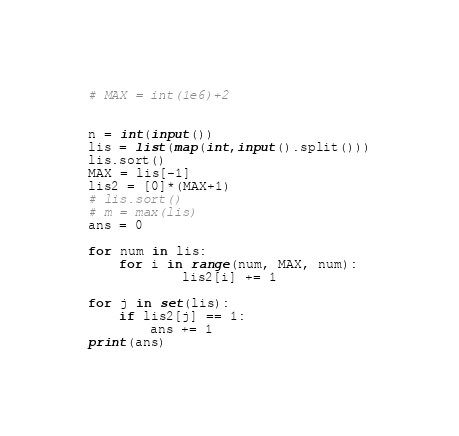<code> <loc_0><loc_0><loc_500><loc_500><_Python_># MAX = int(1e6)+2


n = int(input())
lis = list(map(int,input().split()))
lis.sort()
MAX = lis[-1]
lis2 = [0]*(MAX+1)
# lis.sort()
# m = max(lis)
ans = 0

for num in lis:
    for i in range(num, MAX, num):
            lis2[i] += 1

for j in set(lis):
    if lis2[j] == 1:
        ans += 1
print(ans)</code> 